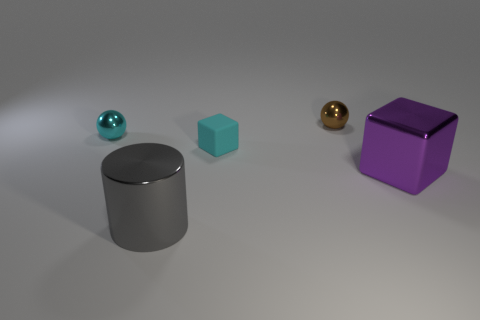Subtract 1 cubes. How many cubes are left? 1 Subtract all balls. How many objects are left? 3 Add 3 tiny metal spheres. How many objects exist? 8 Subtract all gray objects. Subtract all big yellow metal balls. How many objects are left? 4 Add 1 large gray things. How many large gray things are left? 2 Add 5 shiny cylinders. How many shiny cylinders exist? 6 Subtract 0 brown blocks. How many objects are left? 5 Subtract all yellow balls. Subtract all purple blocks. How many balls are left? 2 Subtract all blue blocks. How many brown spheres are left? 1 